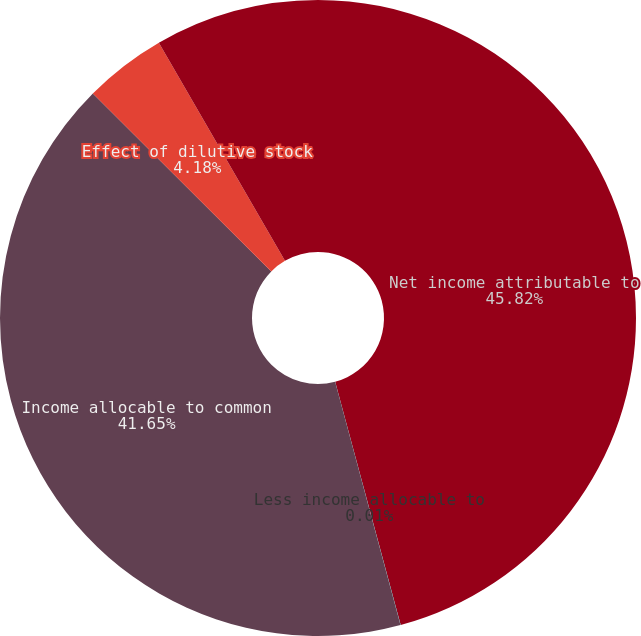Convert chart to OTSL. <chart><loc_0><loc_0><loc_500><loc_500><pie_chart><fcel>Net income attributable to<fcel>Less income allocable to<fcel>Income allocable to common<fcel>Effect of dilutive stock<fcel>Total potential shares<nl><fcel>45.81%<fcel>0.01%<fcel>41.65%<fcel>4.18%<fcel>8.34%<nl></chart> 